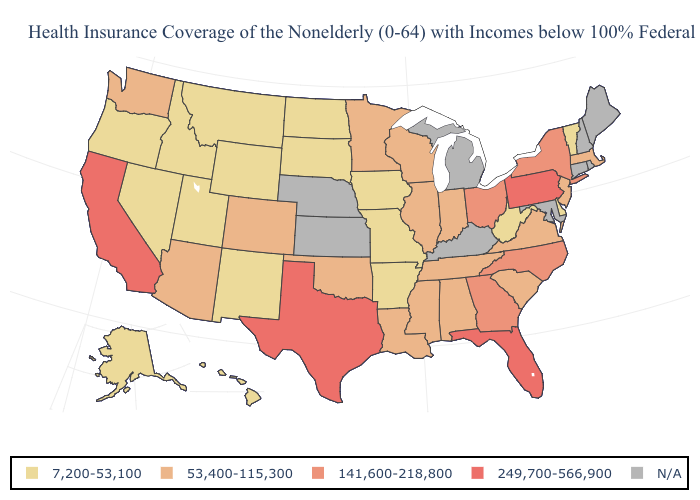What is the lowest value in the West?
Quick response, please. 7,200-53,100. Name the states that have a value in the range 141,600-218,800?
Quick response, please. Georgia, New York, North Carolina, Ohio. Does the first symbol in the legend represent the smallest category?
Give a very brief answer. Yes. What is the value of Indiana?
Short answer required. 53,400-115,300. What is the value of Arizona?
Answer briefly. 53,400-115,300. Name the states that have a value in the range N/A?
Quick response, please. Connecticut, Kansas, Kentucky, Maine, Maryland, Michigan, Nebraska, New Hampshire, Rhode Island. What is the highest value in the MidWest ?
Be succinct. 141,600-218,800. Name the states that have a value in the range 7,200-53,100?
Answer briefly. Alaska, Arkansas, Delaware, Hawaii, Idaho, Iowa, Missouri, Montana, Nevada, New Mexico, North Dakota, Oregon, South Dakota, Utah, Vermont, West Virginia, Wyoming. Name the states that have a value in the range 7,200-53,100?
Keep it brief. Alaska, Arkansas, Delaware, Hawaii, Idaho, Iowa, Missouri, Montana, Nevada, New Mexico, North Dakota, Oregon, South Dakota, Utah, Vermont, West Virginia, Wyoming. What is the value of Georgia?
Short answer required. 141,600-218,800. Does Florida have the highest value in the USA?
Answer briefly. Yes. Among the states that border Vermont , does New York have the lowest value?
Be succinct. No. Which states have the highest value in the USA?
Be succinct. California, Florida, Pennsylvania, Texas. What is the lowest value in the Northeast?
Keep it brief. 7,200-53,100. 